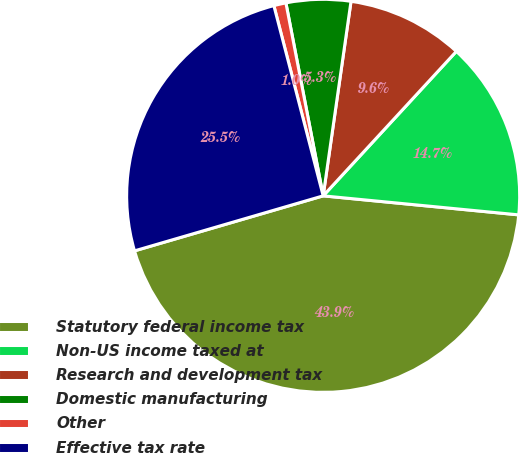<chart> <loc_0><loc_0><loc_500><loc_500><pie_chart><fcel>Statutory federal income tax<fcel>Non-US income taxed at<fcel>Research and development tax<fcel>Domestic manufacturing<fcel>Other<fcel>Effective tax rate<nl><fcel>43.94%<fcel>14.69%<fcel>9.59%<fcel>5.3%<fcel>1.0%<fcel>25.48%<nl></chart> 